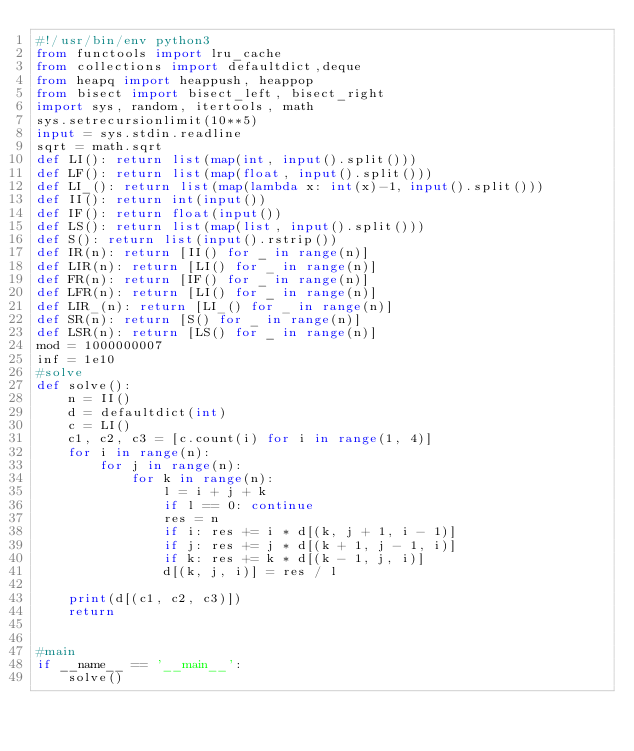Convert code to text. <code><loc_0><loc_0><loc_500><loc_500><_Python_>#!/usr/bin/env python3
from functools import lru_cache
from collections import defaultdict,deque
from heapq import heappush, heappop
from bisect import bisect_left, bisect_right
import sys, random, itertools, math
sys.setrecursionlimit(10**5)
input = sys.stdin.readline
sqrt = math.sqrt
def LI(): return list(map(int, input().split()))
def LF(): return list(map(float, input().split()))
def LI_(): return list(map(lambda x: int(x)-1, input().split()))
def II(): return int(input())
def IF(): return float(input())
def LS(): return list(map(list, input().split()))
def S(): return list(input().rstrip())
def IR(n): return [II() for _ in range(n)]
def LIR(n): return [LI() for _ in range(n)]
def FR(n): return [IF() for _ in range(n)]
def LFR(n): return [LI() for _ in range(n)]
def LIR_(n): return [LI_() for _ in range(n)]
def SR(n): return [S() for _ in range(n)]
def LSR(n): return [LS() for _ in range(n)]
mod = 1000000007
inf = 1e10
#solve
def solve():
    n = II()
    d = defaultdict(int)
    c = LI()
    c1, c2, c3 = [c.count(i) for i in range(1, 4)]
    for i in range(n):
        for j in range(n):
            for k in range(n):
                l = i + j + k
                if l == 0: continue
                res = n
                if i: res += i * d[(k, j + 1, i - 1)]
                if j: res += j * d[(k + 1, j - 1, i)]
                if k: res += k * d[(k - 1, j, i)]
                d[(k, j, i)] = res / l
    
    print(d[(c1, c2, c3)])
    return


#main
if __name__ == '__main__':
    solve()
</code> 